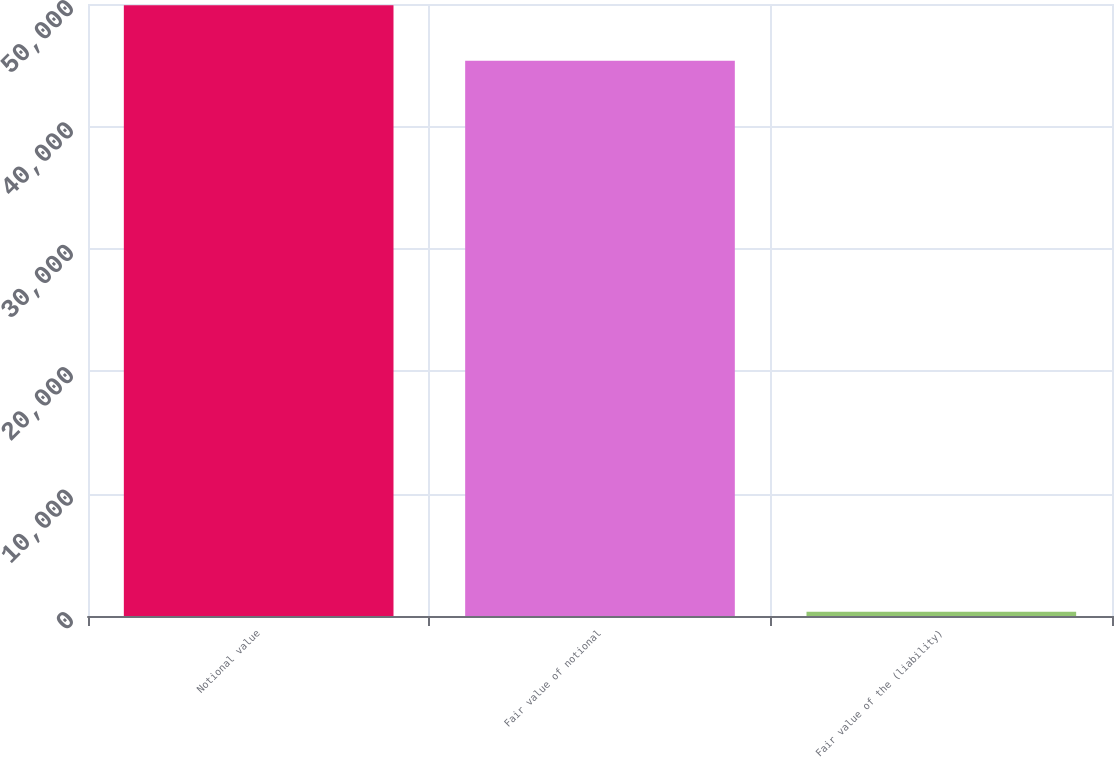<chart> <loc_0><loc_0><loc_500><loc_500><bar_chart><fcel>Notional value<fcel>Fair value of notional<fcel>Fair value of the (liability)<nl><fcel>49898.2<fcel>45362<fcel>354<nl></chart> 